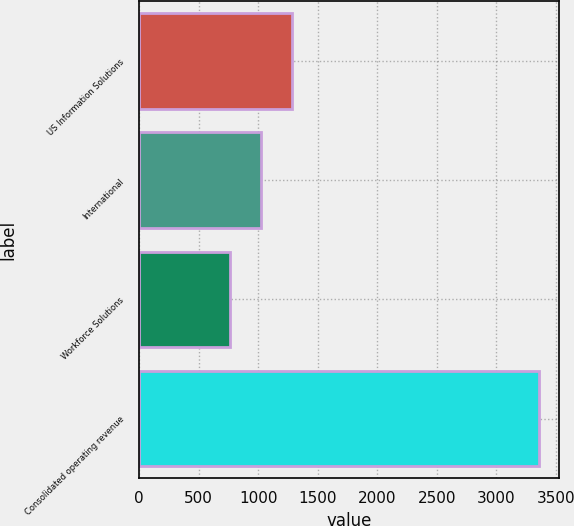Convert chart to OTSL. <chart><loc_0><loc_0><loc_500><loc_500><bar_chart><fcel>US Information Solutions<fcel>International<fcel>Workforce Solutions<fcel>Consolidated operating revenue<nl><fcel>1283.8<fcel>1024<fcel>764.2<fcel>3362.2<nl></chart> 